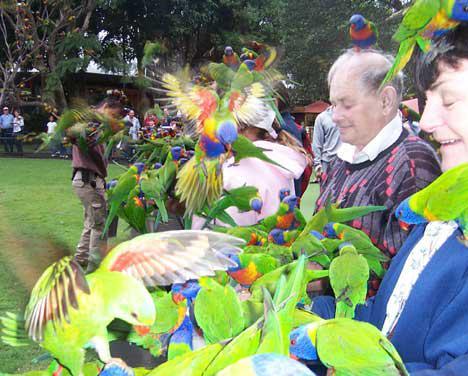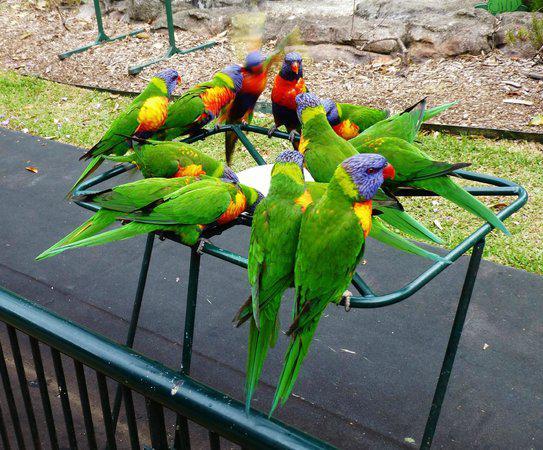The first image is the image on the left, the second image is the image on the right. Analyze the images presented: Is the assertion "The birds are only drinking water in one of the iages." valid? Answer yes or no. Yes. The first image is the image on the left, the second image is the image on the right. Assess this claim about the two images: "birds are standing on a green platform with a bowl in the center on a blacktop sidewalk". Correct or not? Answer yes or no. Yes. 